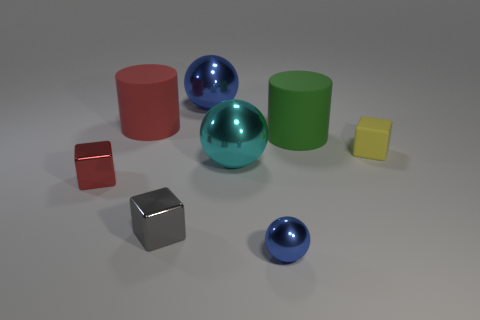What size is the gray metal thing that is the same shape as the small red metallic thing?
Ensure brevity in your answer.  Small. Are there more tiny metallic things that are right of the cyan shiny ball than cyan shiny balls in front of the gray metallic object?
Give a very brief answer. Yes. Do the small sphere and the ball that is behind the big green cylinder have the same material?
Provide a succinct answer. Yes. The object that is on the left side of the tiny gray metallic thing and behind the big green matte cylinder is what color?
Ensure brevity in your answer.  Red. What is the shape of the tiny thing right of the tiny ball?
Make the answer very short. Cube. What is the size of the ball on the right side of the big ball on the right side of the big sphere that is behind the yellow rubber object?
Your answer should be very brief. Small. There is a blue object that is in front of the yellow matte cube; what number of big cylinders are to the left of it?
Make the answer very short. 1. There is a cube that is right of the red cylinder and on the left side of the cyan ball; how big is it?
Provide a succinct answer. Small. What number of shiny things are cyan blocks or large green objects?
Give a very brief answer. 0. What material is the tiny gray object?
Offer a very short reply. Metal. 